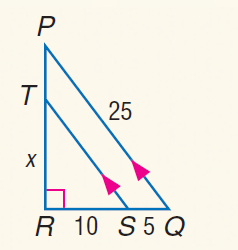Answer the mathemtical geometry problem and directly provide the correct option letter.
Question: Find x.
Choices: A: 12 B: 26 / 2 C: \frac { 40 } { 3 } D: 14 C 